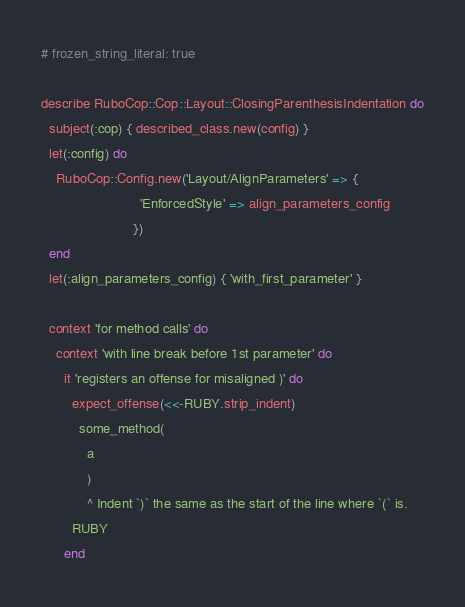Convert code to text. <code><loc_0><loc_0><loc_500><loc_500><_Ruby_># frozen_string_literal: true

describe RuboCop::Cop::Layout::ClosingParenthesisIndentation do
  subject(:cop) { described_class.new(config) }
  let(:config) do
    RuboCop::Config.new('Layout/AlignParameters' => {
                          'EnforcedStyle' => align_parameters_config
                        })
  end
  let(:align_parameters_config) { 'with_first_parameter' }

  context 'for method calls' do
    context 'with line break before 1st parameter' do
      it 'registers an offense for misaligned )' do
        expect_offense(<<-RUBY.strip_indent)
          some_method(
            a
            )
            ^ Indent `)` the same as the start of the line where `(` is.
        RUBY
      end
</code> 